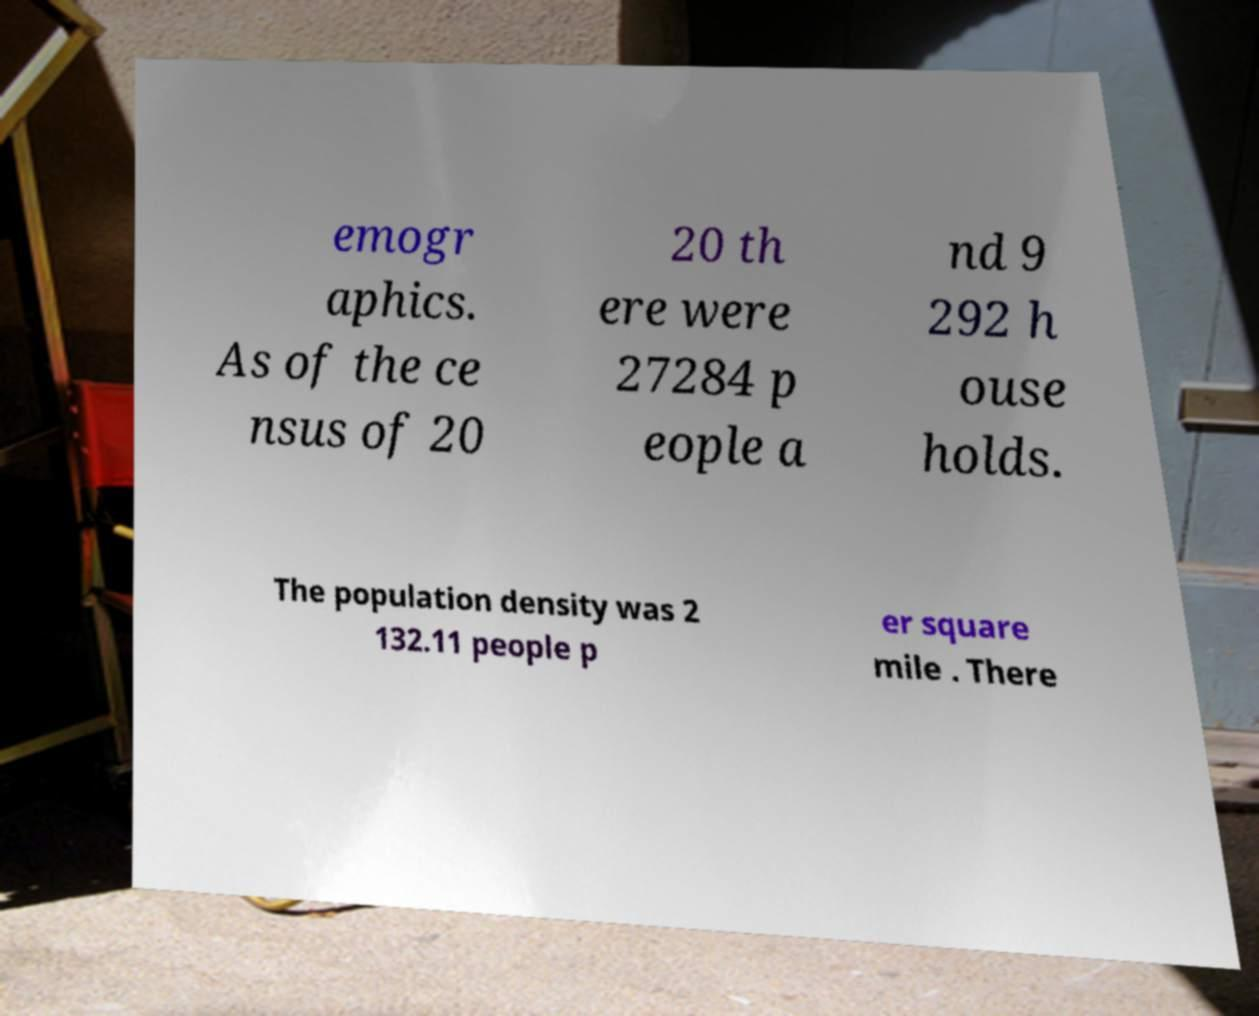Could you assist in decoding the text presented in this image and type it out clearly? emogr aphics. As of the ce nsus of 20 20 th ere were 27284 p eople a nd 9 292 h ouse holds. The population density was 2 132.11 people p er square mile . There 